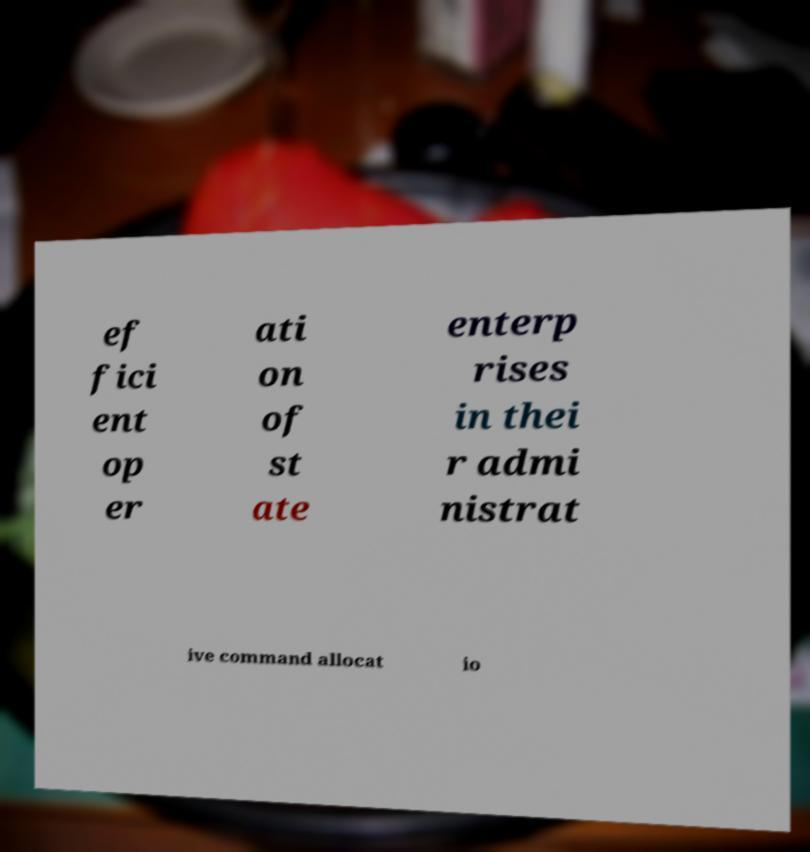Please identify and transcribe the text found in this image. ef fici ent op er ati on of st ate enterp rises in thei r admi nistrat ive command allocat io 